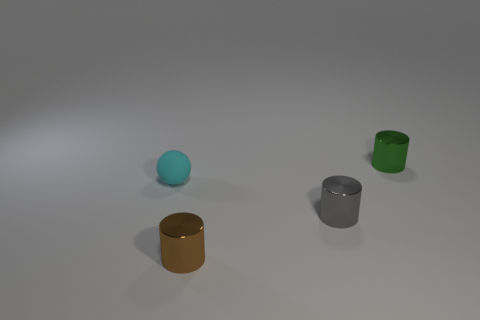What could be the possible sizes of these objects in relation to each other? Based on the perspective provided, the objects appear to vary in size. The cyan ball seems to be the smallest, while the green cylinder looks slightly taller. The golden cylinder appears to have the largest diameter, and the silver cylinder, although similar in height to the green one, seems to have a slightly larger diameter as well. Could you estimate their real-world dimensions? Without a reference object for scale, exact dimensions are speculative. However, the objects could be comparable in size to common household items: the cyan ball akin to a small marble, the cylinders similar to containers or cups, each possibly standing around 8 to 12 centimeters tall. 